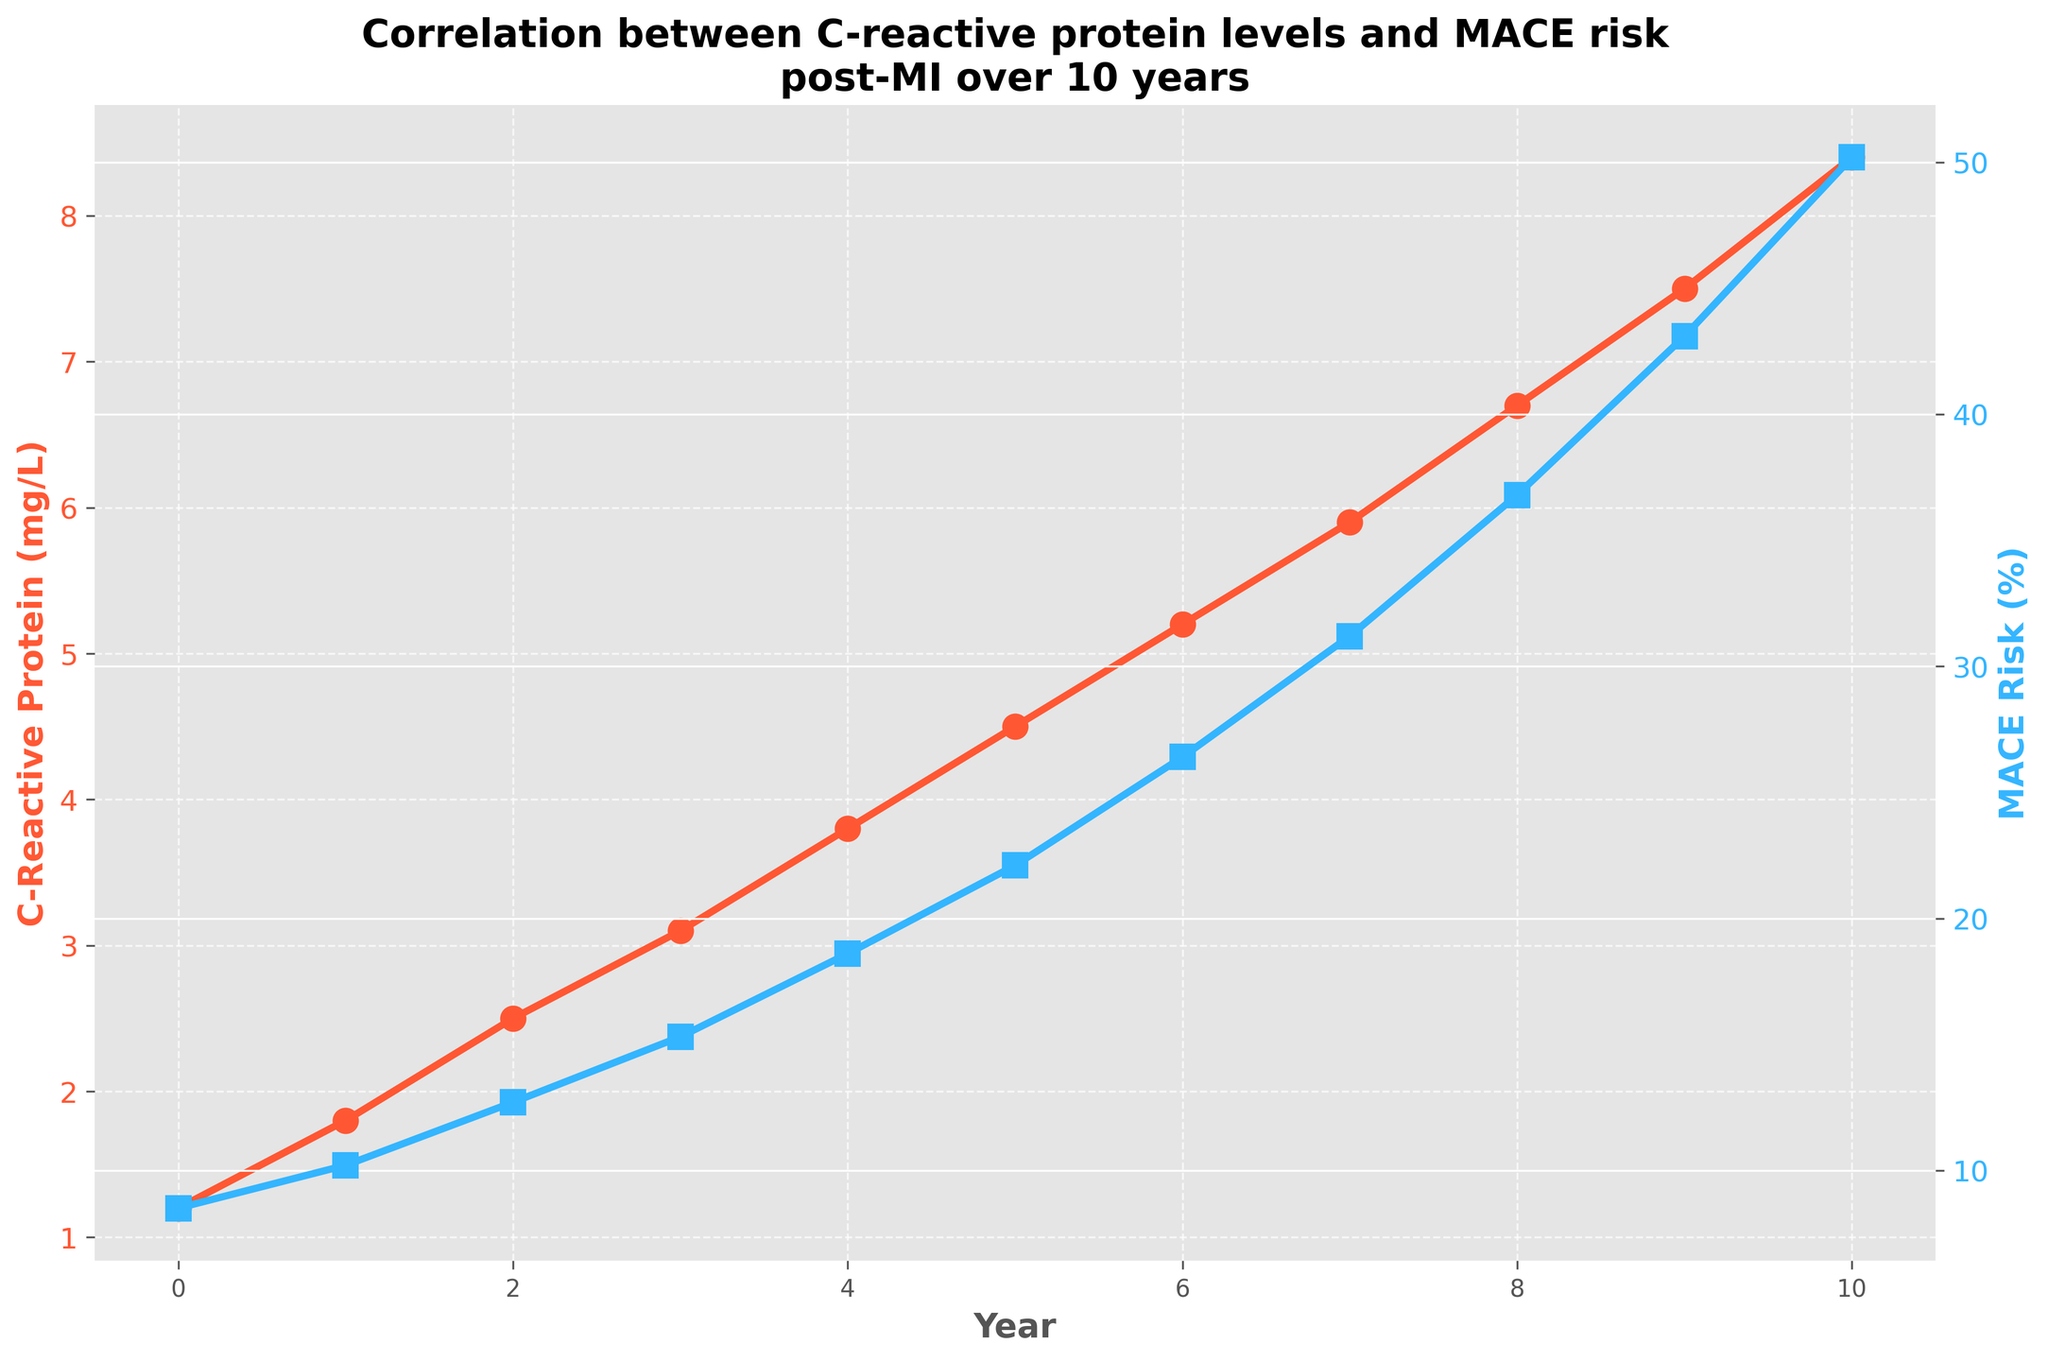What is the initial level of C-reactive protein? At Year 0, the C-reactive protein level is found directly from the plot where the red line starts.
Answer: 1.2 mg/L What was the MACE Risk at Year 5? By looking at the blue line at Year 5, you can see that the MACE Risk is represented by the corresponding data point.
Answer: 22.1% Which year has the greatest increase in MACE Risk from the previous year? Calculate the differences in MACE Risk between each sequential year and compare them. The largest increase occurs between Year 9 and Year 10.
Answer: Year 10 Compare the C-reactive protein levels between Year 3 and Year 7. Which year has a higher level? Follow the red line to Year 3 and Year 7 and observe that Year 7 has a higher C-reactive protein value compared to Year 3.
Answer: Year 7 If the trend continues, what would you infer about the MACE Risk at Year 12? The MACE Risk increases approximately exponentially, with steeper increases over time. If this trend continues without a specific calculated prediction, it would likely be well above 50%.
Answer: Above 50% What is the combined level of C-reactive protein for the first 3 years? Sum together the values at Year 0, Year 1, and Year 2 from the plot: 1.2 + 1.8 + 2.5 = 5.5 mg/L.
Answer: 5.5 mg/L Compare the slopes of the C-reactive protein and MACE Risk lines between Year 3 and Year 5. Which slope is steeper? Analyze the gradient from Years 3 to 5 for both the red and blue lines. The slope of the MACE Risk line (blue) increases more rapidly than the C-reactive Protein line (red).
Answer: MACE Risk slope At what year does the C-reactive protein level surpass 4 mg/L? Observing the red line, the C-reactive protein level crosses 4 mg/L between Years 4 and 5.
Answer: Year 5 